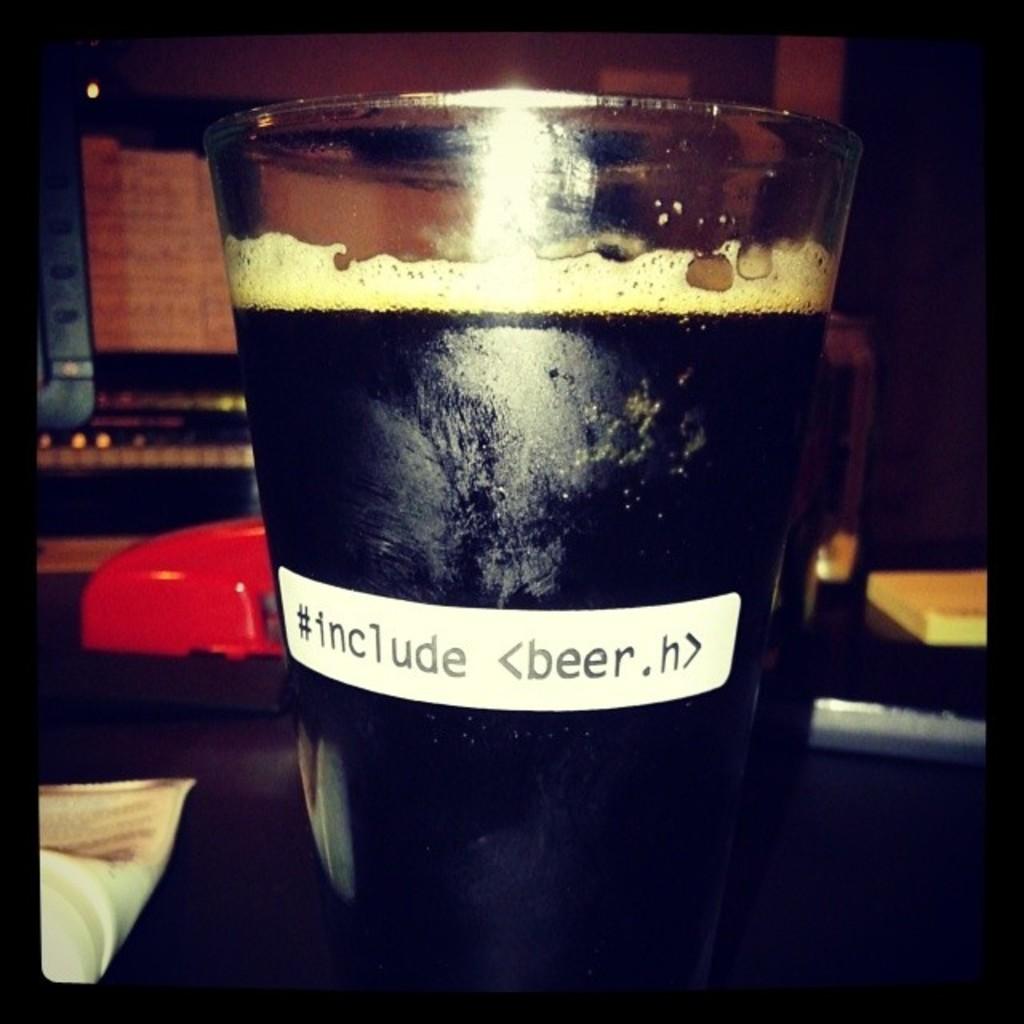What is included in the cup?
Your answer should be very brief. Beer. 